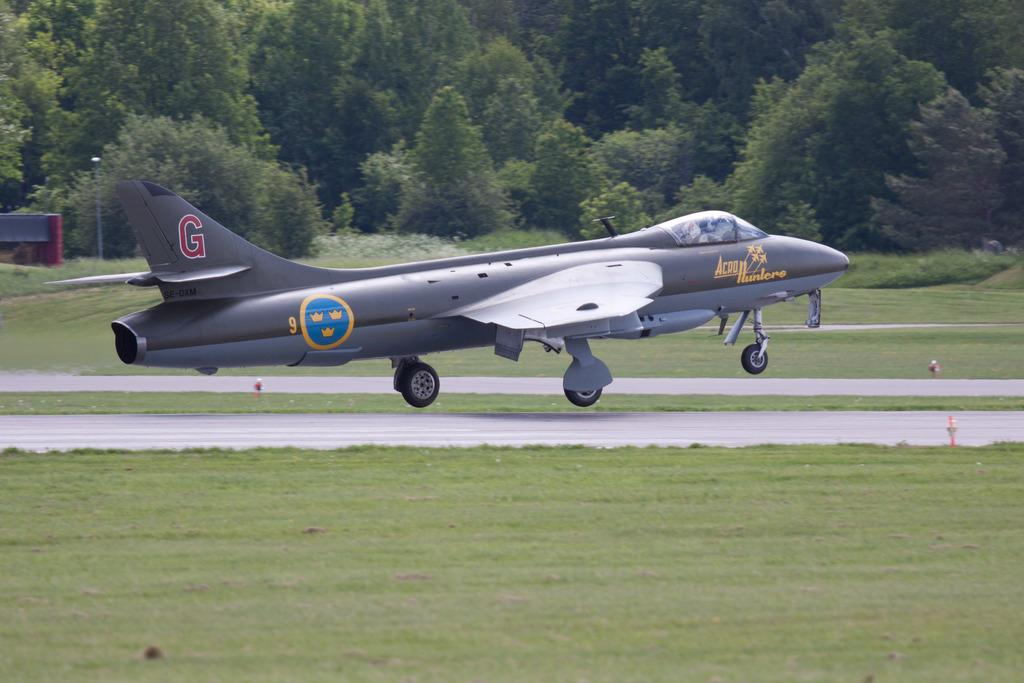<image>
Create a compact narrative representing the image presented. An airplane with a logo for AeroHunters at the front and a large G at the tail. 